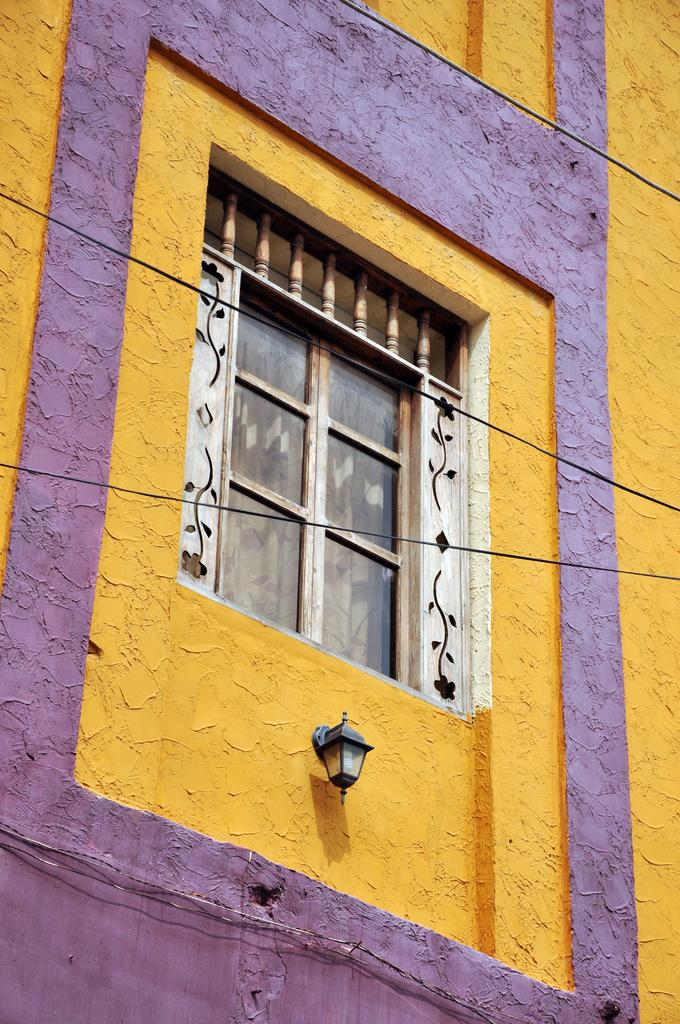What type of structure is visible in the image? There is a building in the image. Can you describe any specific features of the building? There is a window in the building. What other objects can be seen in the image? There is a lamp in the image. What type of oven can be seen in the image? There is no oven present in the image. Can you describe the popcorn being prepared in the image? There is no popcorn or preparation process visible in the image. 